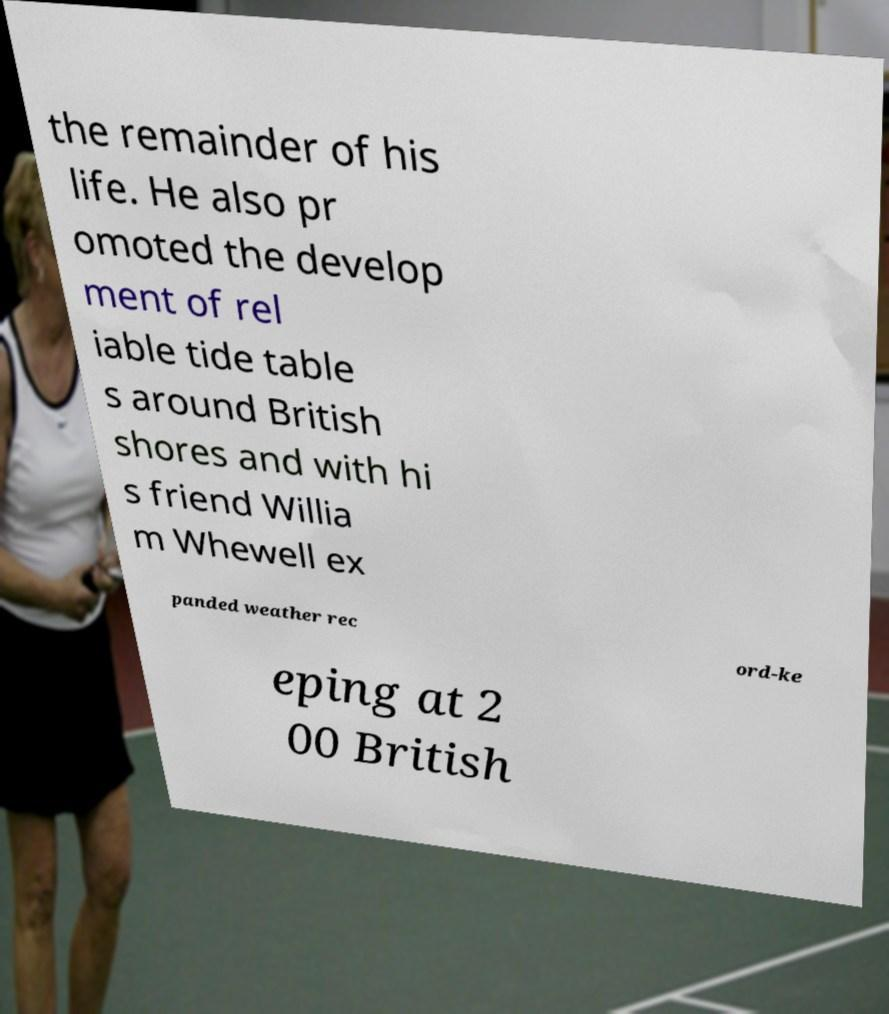Could you extract and type out the text from this image? the remainder of his life. He also pr omoted the develop ment of rel iable tide table s around British shores and with hi s friend Willia m Whewell ex panded weather rec ord-ke eping at 2 00 British 